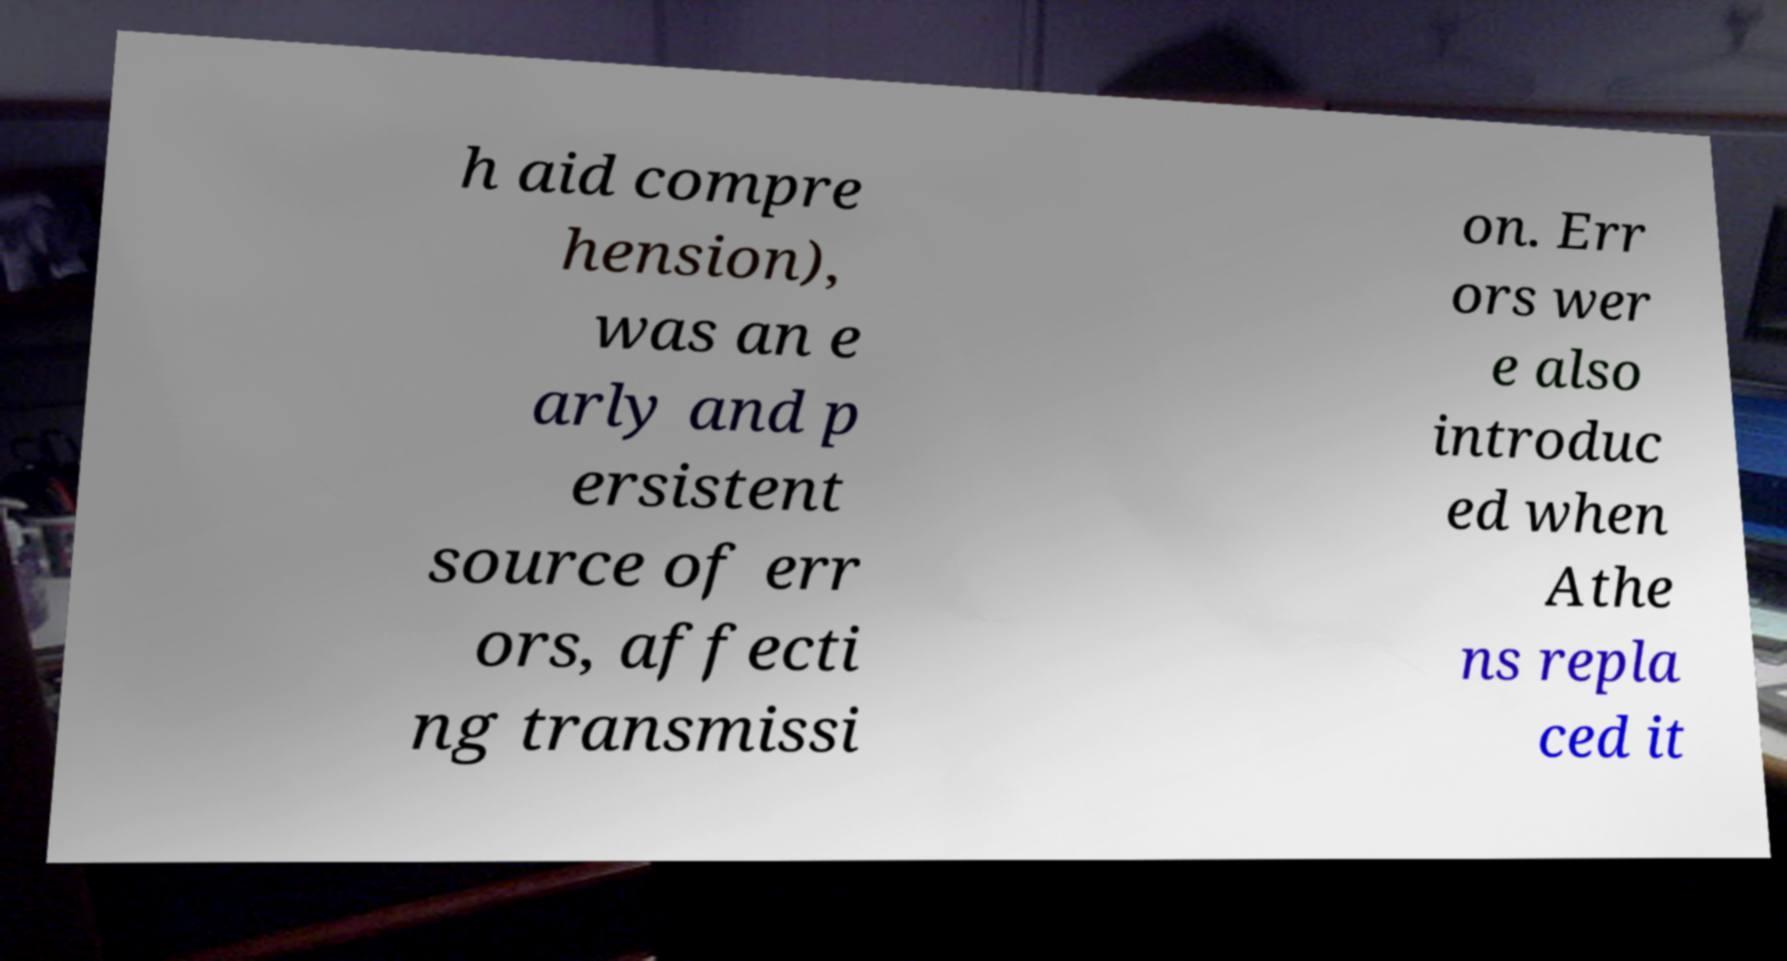Can you read and provide the text displayed in the image?This photo seems to have some interesting text. Can you extract and type it out for me? h aid compre hension), was an e arly and p ersistent source of err ors, affecti ng transmissi on. Err ors wer e also introduc ed when Athe ns repla ced it 